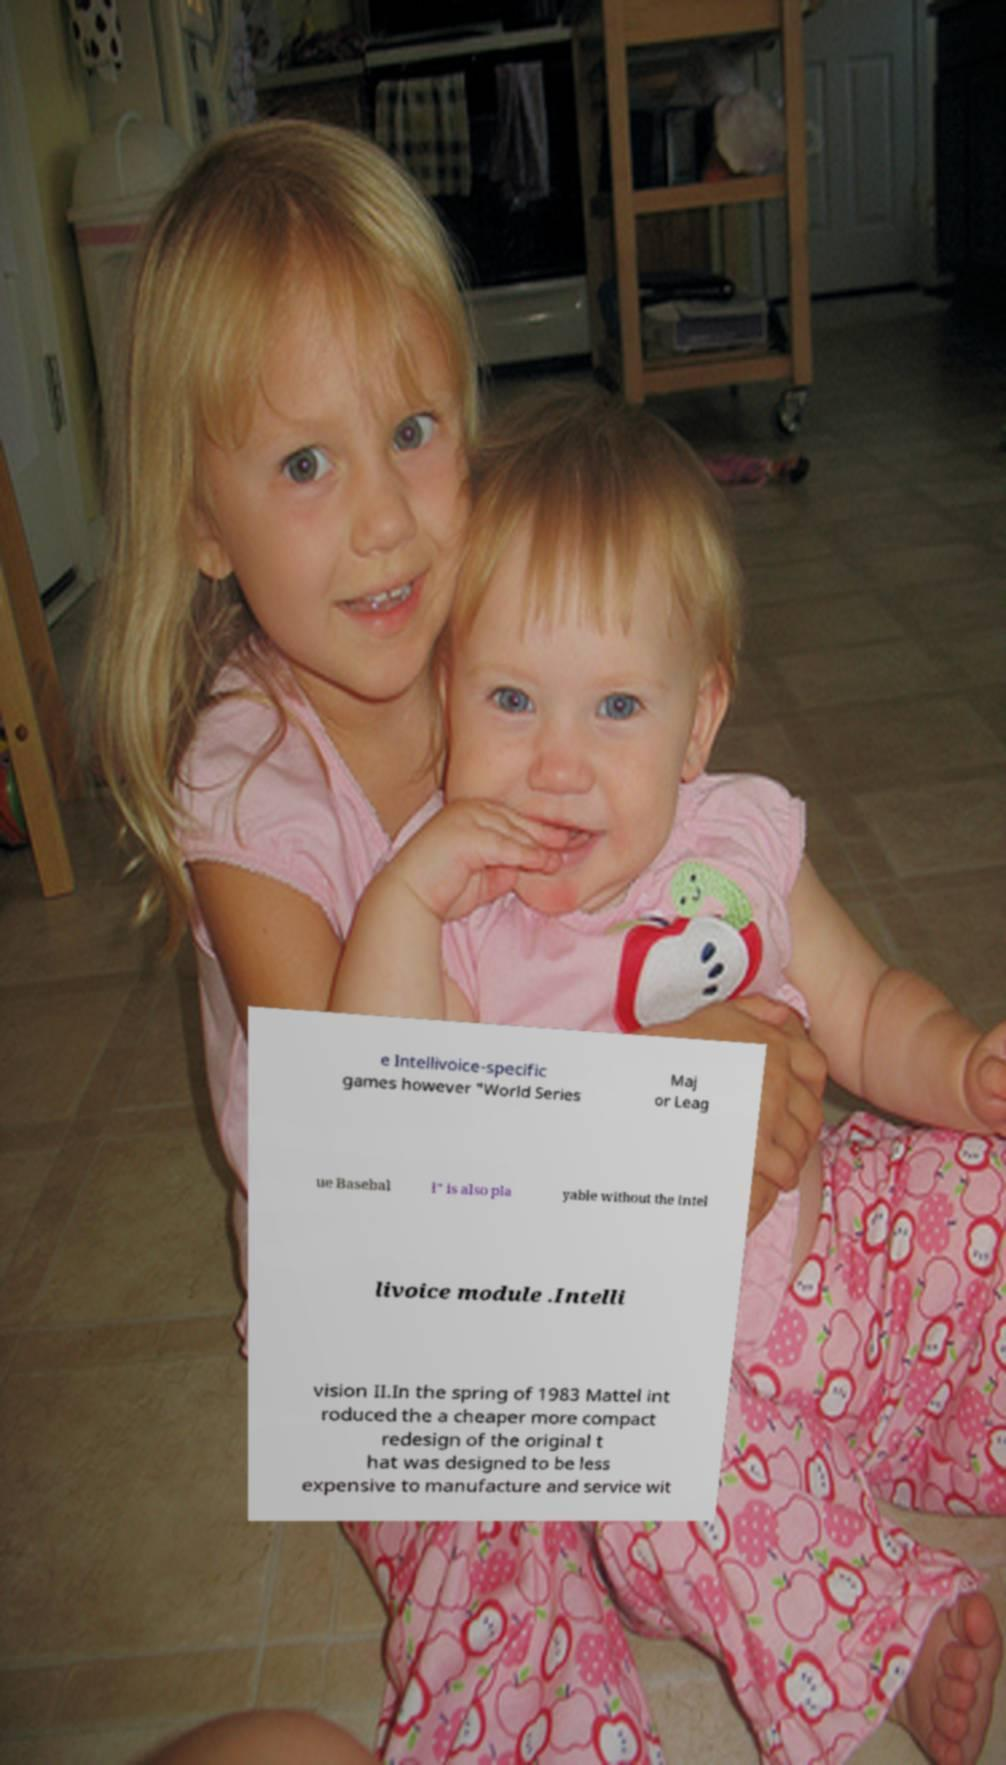What messages or text are displayed in this image? I need them in a readable, typed format. e Intellivoice-specific games however "World Series Maj or Leag ue Basebal l" is also pla yable without the Intel livoice module .Intelli vision II.In the spring of 1983 Mattel int roduced the a cheaper more compact redesign of the original t hat was designed to be less expensive to manufacture and service wit 